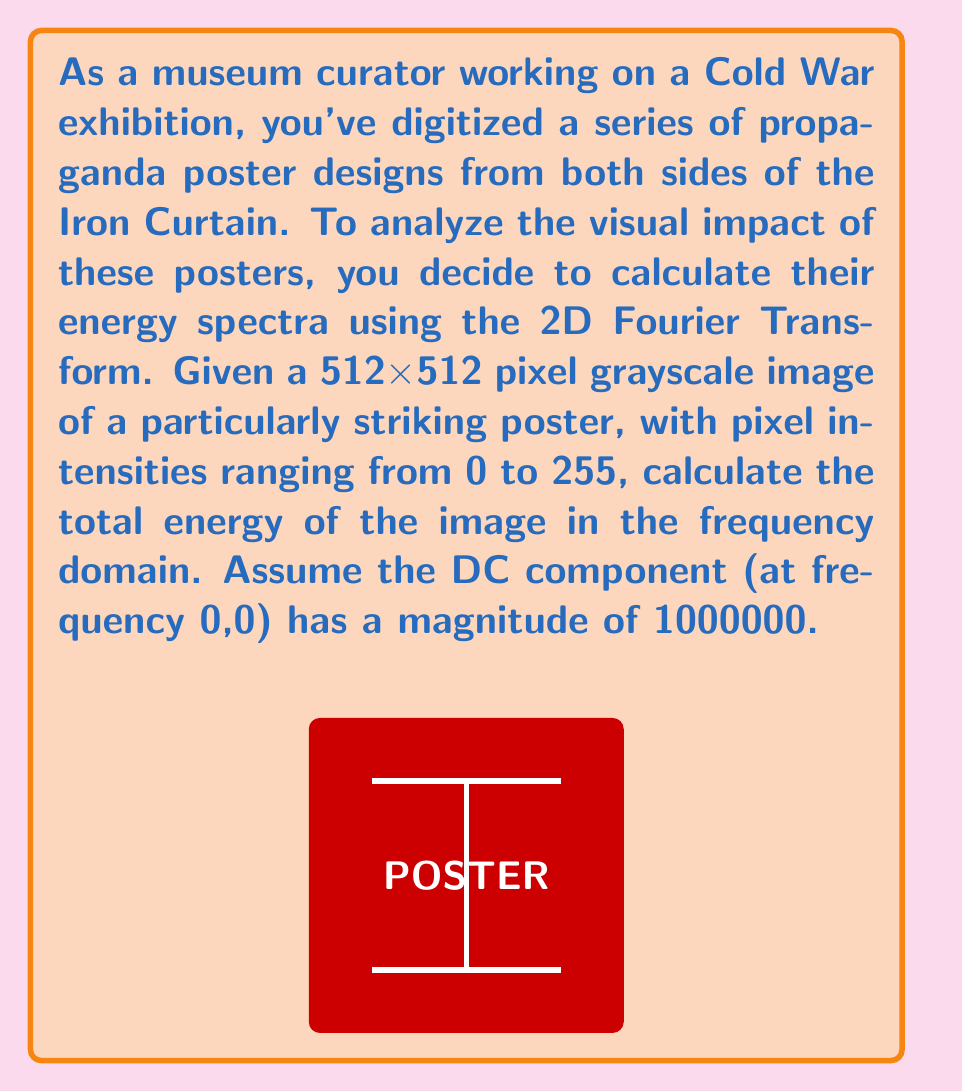Teach me how to tackle this problem. To calculate the energy spectrum of the propaganda poster design, we'll follow these steps:

1) The 2D Fourier Transform converts the image from the spatial domain to the frequency domain. For a discrete image of size MxN, the Fourier Transform is given by:

   $$F(u,v) = \sum_{x=0}^{M-1} \sum_{y=0}^{N-1} f(x,y) e^{-j2\pi(\frac{ux}{M} + \frac{vy}{N})}$$

   where f(x,y) is the pixel intensity at position (x,y).

2) The energy spectrum is the squared magnitude of the Fourier Transform:

   $$E(u,v) = |F(u,v)|^2$$

3) The total energy is the sum of the energy spectrum over all frequencies:

   $$E_{total} = \sum_{u=0}^{M-1} \sum_{v=0}^{N-1} E(u,v)$$

4) In this case, we're given that the DC component (F(0,0)) has a magnitude of 1000000. Therefore:

   $$E(0,0) = |F(0,0)|^2 = 1000000^2 = 10^{12}$$

5) For all other frequencies, we need to calculate the energy. However, we don't have the actual image data. In a real scenario, we would compute this for each frequency.

6) Due to Parseval's theorem, the total energy in the frequency domain is equal to the total energy in the spatial domain:

   $$\sum_{u=0}^{M-1} \sum_{v=0}^{N-1} |F(u,v)|^2 = \sum_{x=0}^{M-1} \sum_{y=0}^{N-1} |f(x,y)|^2$$

7) In the spatial domain, we can calculate the maximum possible energy:
   - Image size: 512 x 512 = 262144 pixels
   - Maximum pixel intensity: 255
   - Maximum energy: $262144 * 255^2 = 17,039,360,000$

8) The actual total energy will be the sum of the DC component energy and the energy from all other frequencies, which will be less than or equal to the maximum calculated in step 7.

9) Therefore, the total energy will be slightly more than $10^{12}$ (from the DC component) but less than $1.017 \times 10^{13}$ (DC component + maximum possible from other frequencies).
Answer: $E_{total} \approx 10^{12}$ to $1.017 \times 10^{13}$ 